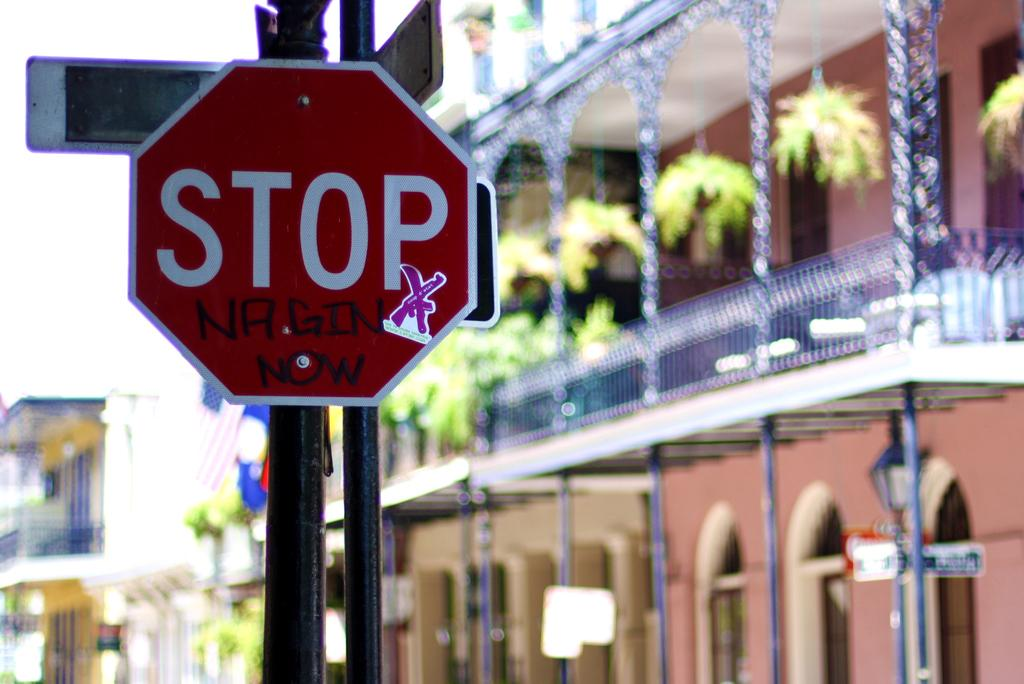<image>
Describe the image concisely. A stop in the French Quarter with graffiti on it. 